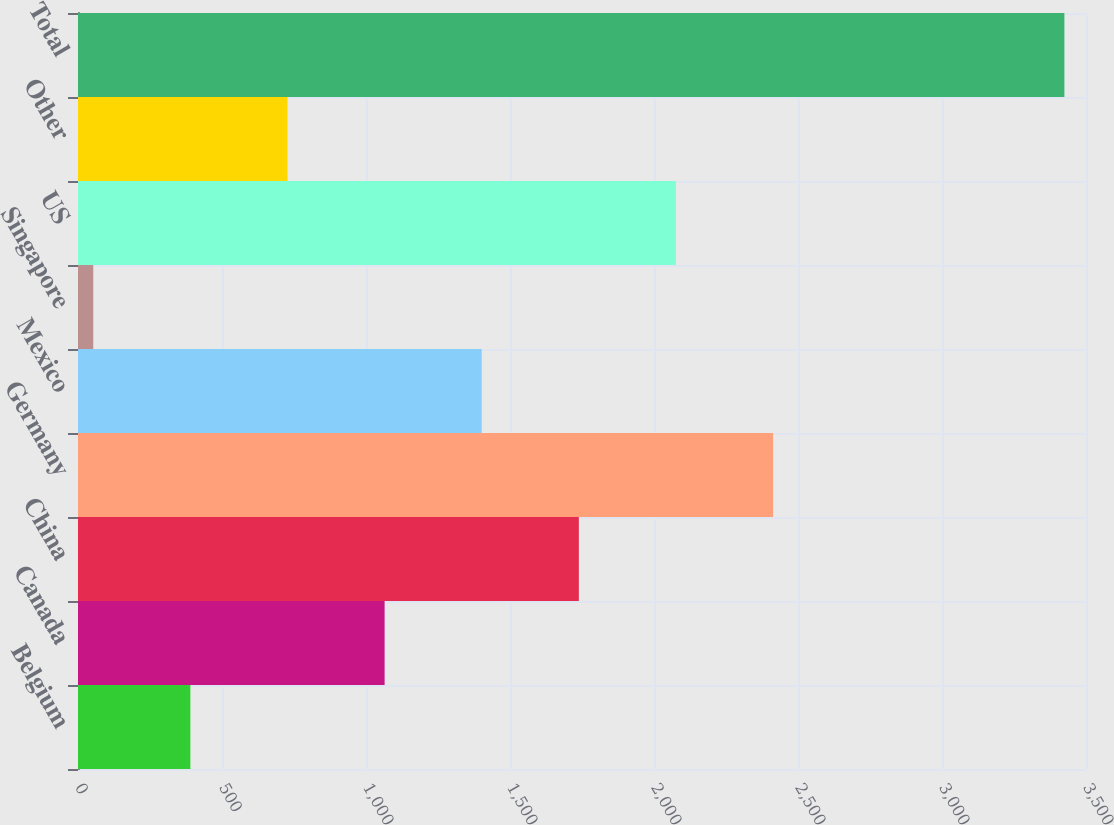<chart> <loc_0><loc_0><loc_500><loc_500><bar_chart><fcel>Belgium<fcel>Canada<fcel>China<fcel>Germany<fcel>Mexico<fcel>Singapore<fcel>US<fcel>Other<fcel>Total<nl><fcel>390.2<fcel>1064.6<fcel>1739<fcel>2413.4<fcel>1401.8<fcel>53<fcel>2076.2<fcel>727.4<fcel>3425<nl></chart> 